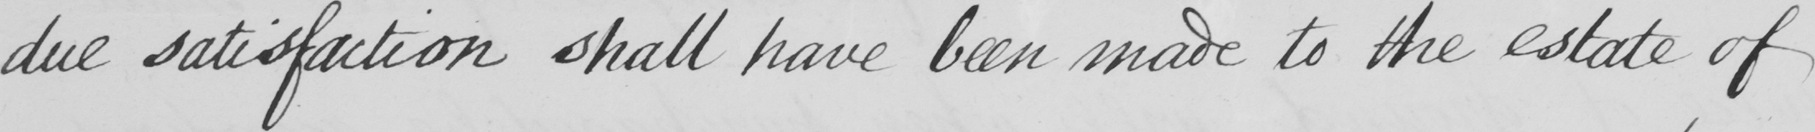Can you read and transcribe this handwriting? due satisfaction shall have been made to the estate of 